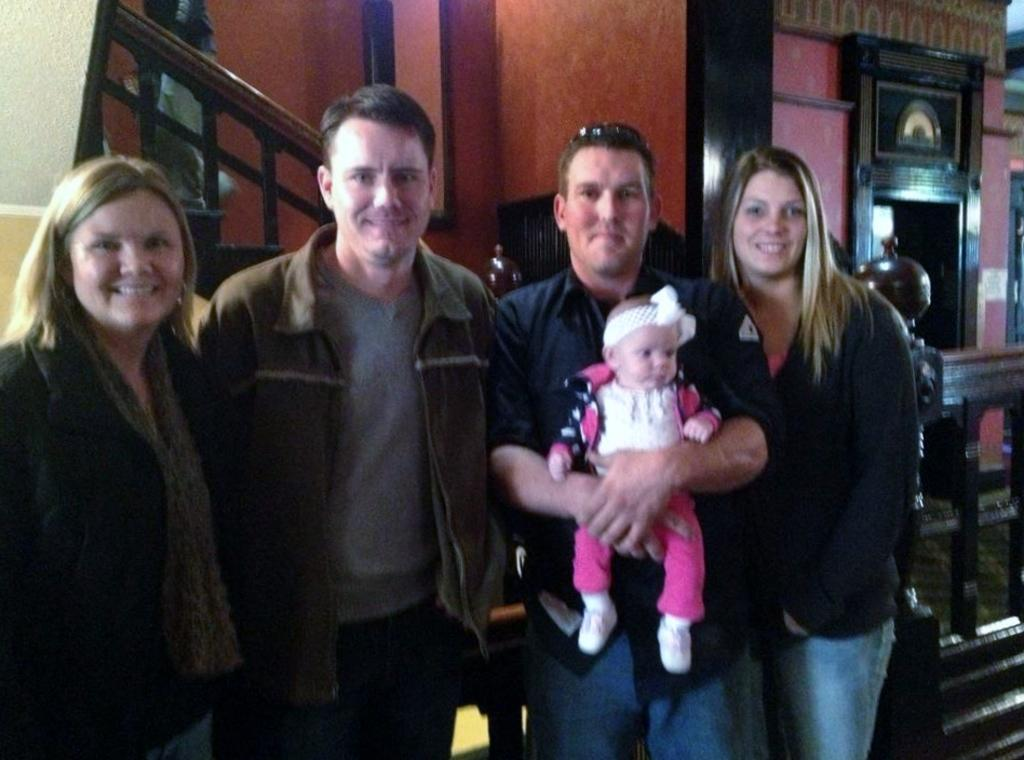How many people are in the image? There are four people standing and smiling in the image. What is one of the men doing in the image? One man is holding a baby. Can you describe the location of the person on the stairs? There is a person on the stairs in the image. What type of thrill can be seen on the floor in the image? There is no thrill or any object related to thrill present on the floor in the image. 